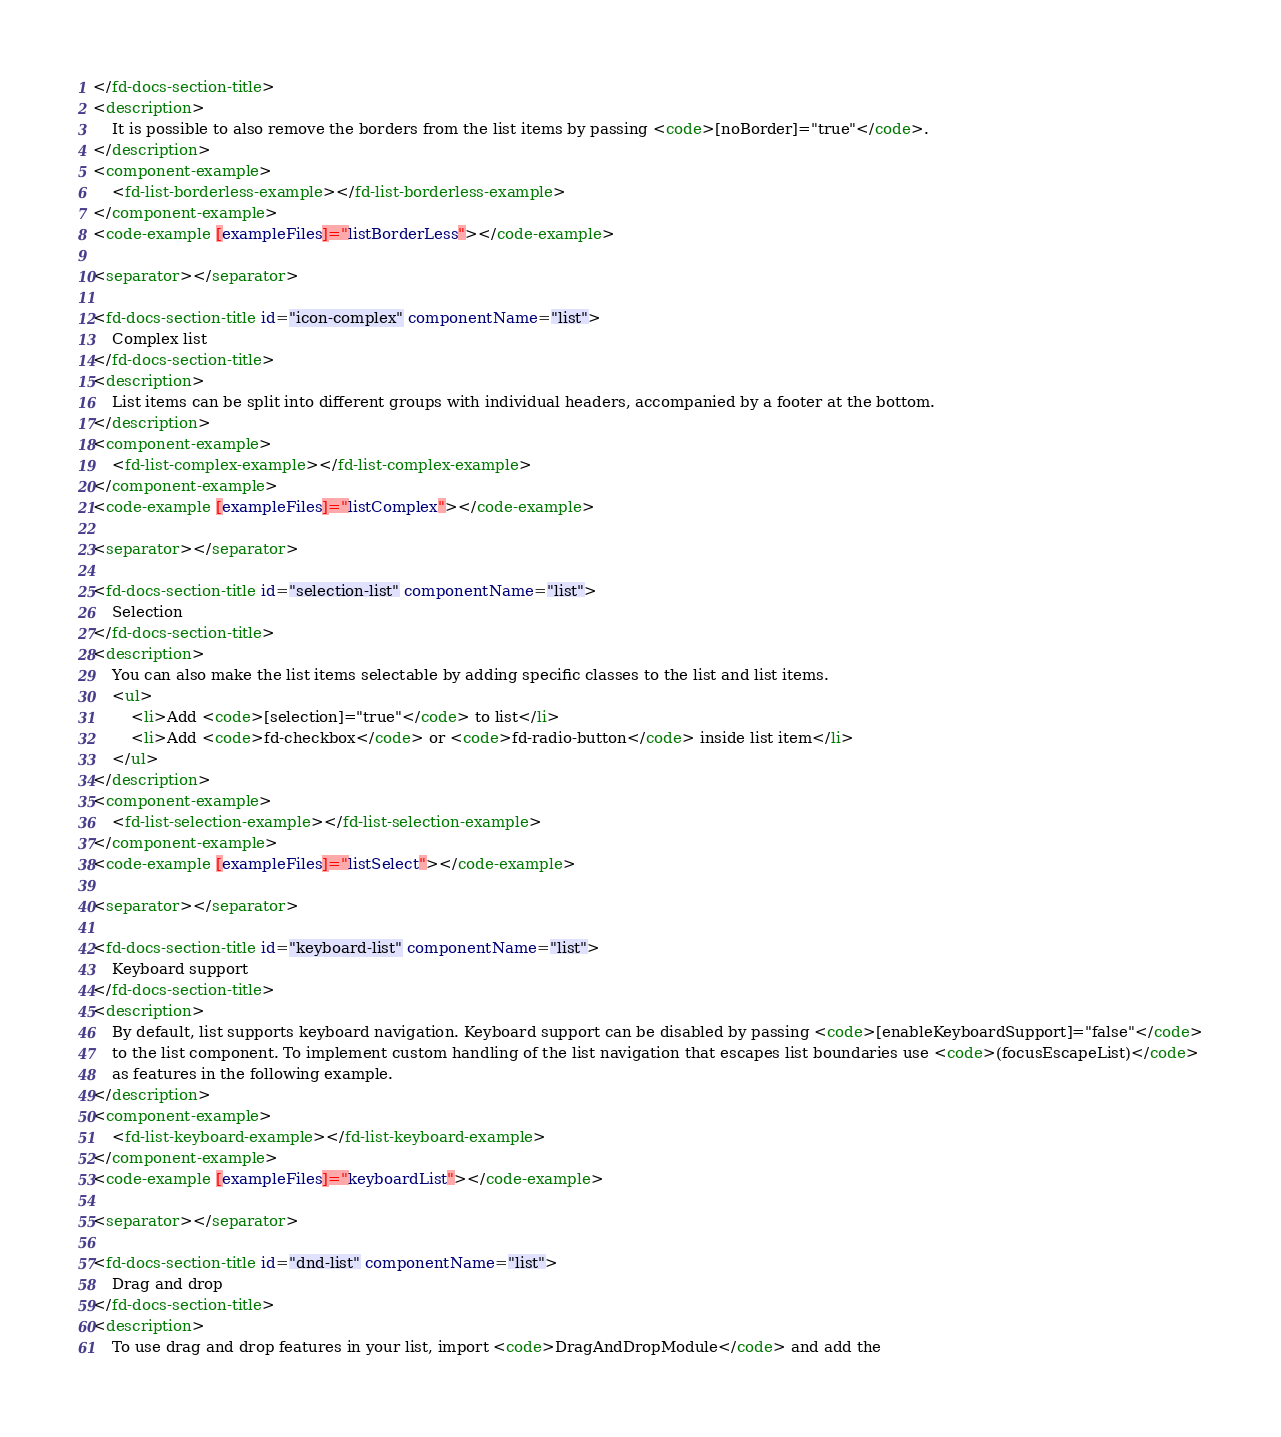Convert code to text. <code><loc_0><loc_0><loc_500><loc_500><_HTML_></fd-docs-section-title>
<description>
    It is possible to also remove the borders from the list items by passing <code>[noBorder]="true"</code>.
</description>
<component-example>
    <fd-list-borderless-example></fd-list-borderless-example>
</component-example>
<code-example [exampleFiles]="listBorderLess"></code-example>

<separator></separator>

<fd-docs-section-title id="icon-complex" componentName="list">
    Complex list
</fd-docs-section-title>
<description>
    List items can be split into different groups with individual headers, accompanied by a footer at the bottom.
</description>
<component-example>
    <fd-list-complex-example></fd-list-complex-example>
</component-example>
<code-example [exampleFiles]="listComplex"></code-example>

<separator></separator>

<fd-docs-section-title id="selection-list" componentName="list">
    Selection
</fd-docs-section-title>
<description>
    You can also make the list items selectable by adding specific classes to the list and list items.
    <ul>
        <li>Add <code>[selection]="true"</code> to list</li>
        <li>Add <code>fd-checkbox</code> or <code>fd-radio-button</code> inside list item</li>
    </ul>
</description>
<component-example>
    <fd-list-selection-example></fd-list-selection-example>
</component-example>
<code-example [exampleFiles]="listSelect"></code-example>

<separator></separator>

<fd-docs-section-title id="keyboard-list" componentName="list">
    Keyboard support
</fd-docs-section-title>
<description>
    By default, list supports keyboard navigation. Keyboard support can be disabled by passing <code>[enableKeyboardSupport]="false"</code>
    to the list component. To implement custom handling of the list navigation that escapes list boundaries use <code>(focusEscapeList)</code>
    as features in the following example.
</description>
<component-example>
    <fd-list-keyboard-example></fd-list-keyboard-example>
</component-example>
<code-example [exampleFiles]="keyboardList"></code-example>

<separator></separator>

<fd-docs-section-title id="dnd-list" componentName="list">
    Drag and drop
</fd-docs-section-title>
<description>
    To use drag and drop features in your list, import <code>DragAndDropModule</code> and add the</code> 